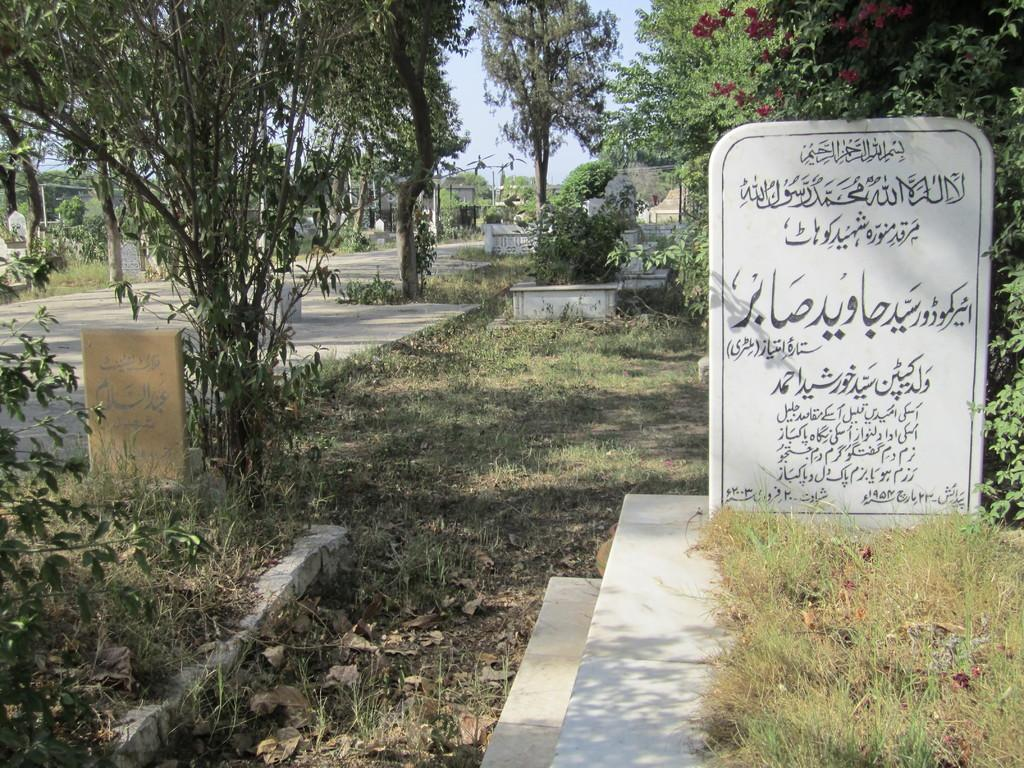What type of structures can be seen in the image? There are gravestones in the image. What type of vegetation is present in the image? There are trees, plants, and grass in the image. What is on the ground in the image? There are leaves on the ground in the image. What part of the natural environment is visible in the image? The sky is visible in the image. What type of marble is being used for the protest signs in the image? There is no protest or protest signs present in the image, so there is no marble being used. 